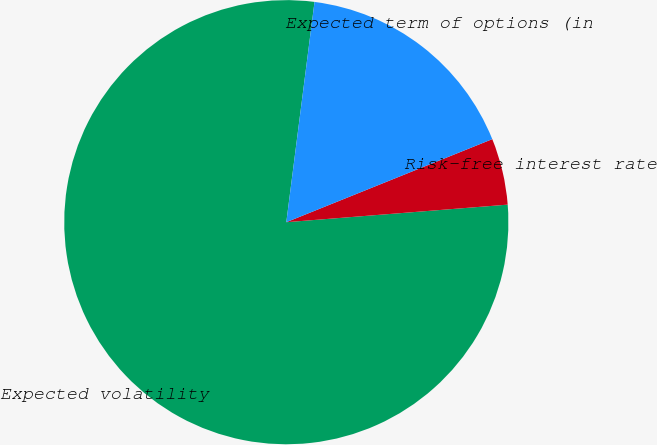<chart> <loc_0><loc_0><loc_500><loc_500><pie_chart><fcel>Expected volatility<fcel>Risk-free interest rate<fcel>Expected term of options (in<nl><fcel>78.28%<fcel>4.84%<fcel>16.87%<nl></chart> 